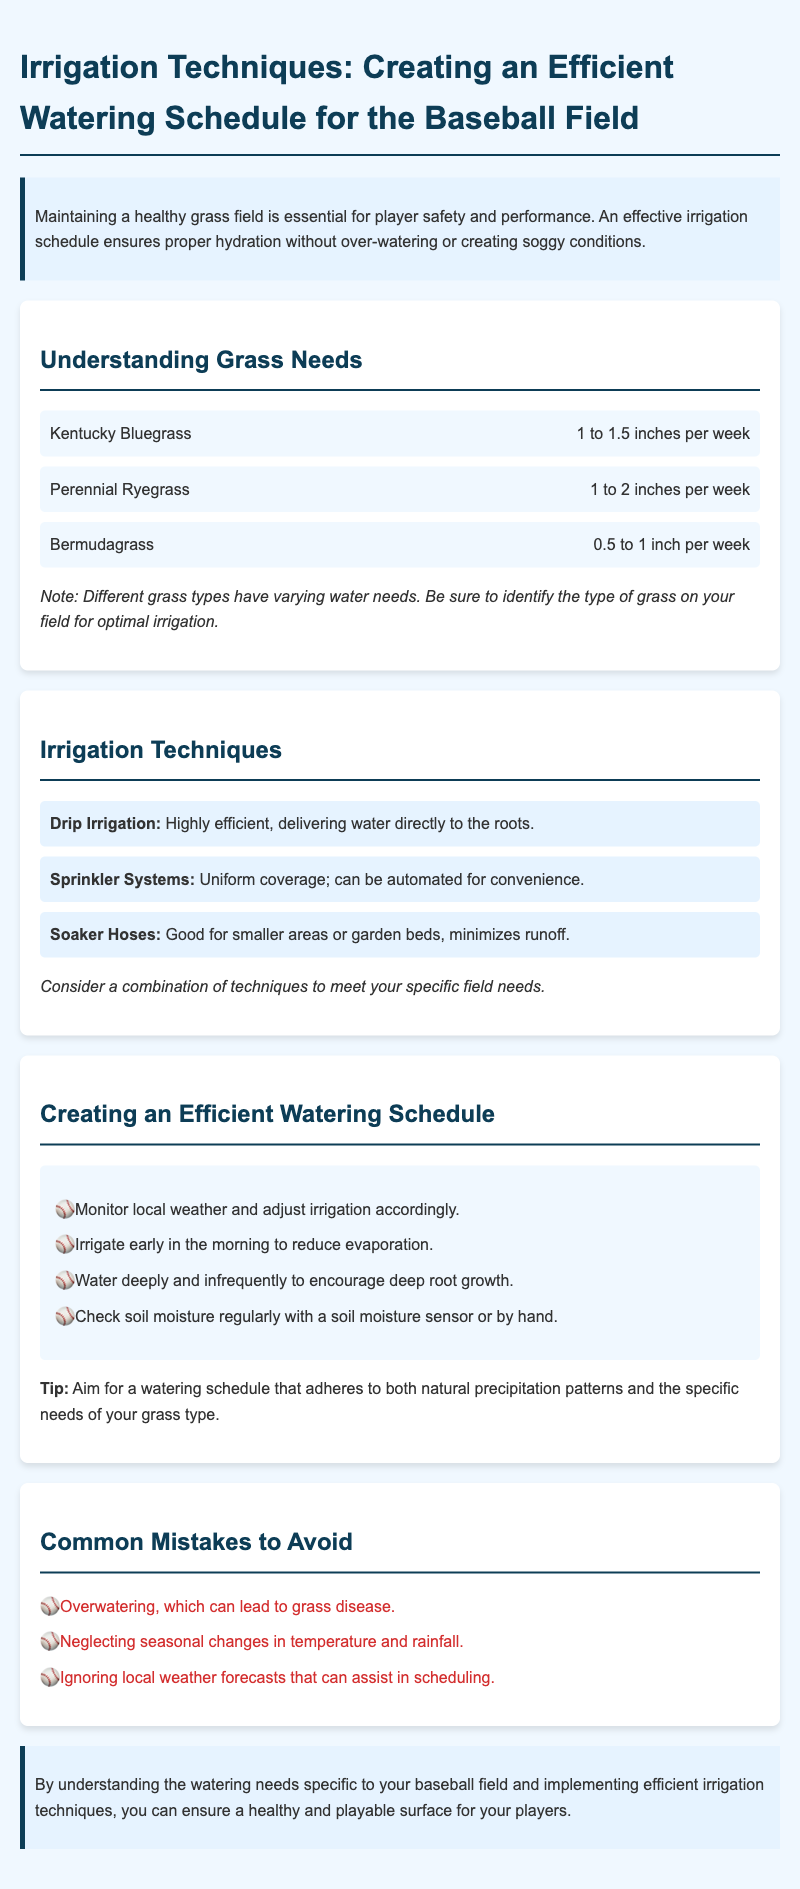What type of grass requires 1 to 1.5 inches of water per week? The document states that Kentucky Bluegrass has a water requirement of 1 to 1.5 inches per week.
Answer: Kentucky Bluegrass What is the recommended watering time to reduce evaporation? The document suggests irrigating early in the morning to reduce evaporation.
Answer: Early in the morning Which irrigation technique delivers water directly to the roots? The document states that Drip Irrigation delivers water directly to the roots.
Answer: Drip Irrigation What is a common mistake to avoid according to the document? The document lists overwatering as a common mistake to avoid when maintaining the grass.
Answer: Overwatering How much water does Bermudagrass need per week? The document indicates that Bermudagrass requires 0.5 to 1 inch of water per week.
Answer: 0.5 to 1 inch What should you do to encourage deep root growth? The document advises watering deeply and infrequently to promote deep root growth.
Answer: Water deeply and infrequently What is essential for player safety and performance? The document emphasizes that maintaining a healthy grass field is essential for both player safety and performance.
Answer: Healthy grass field 